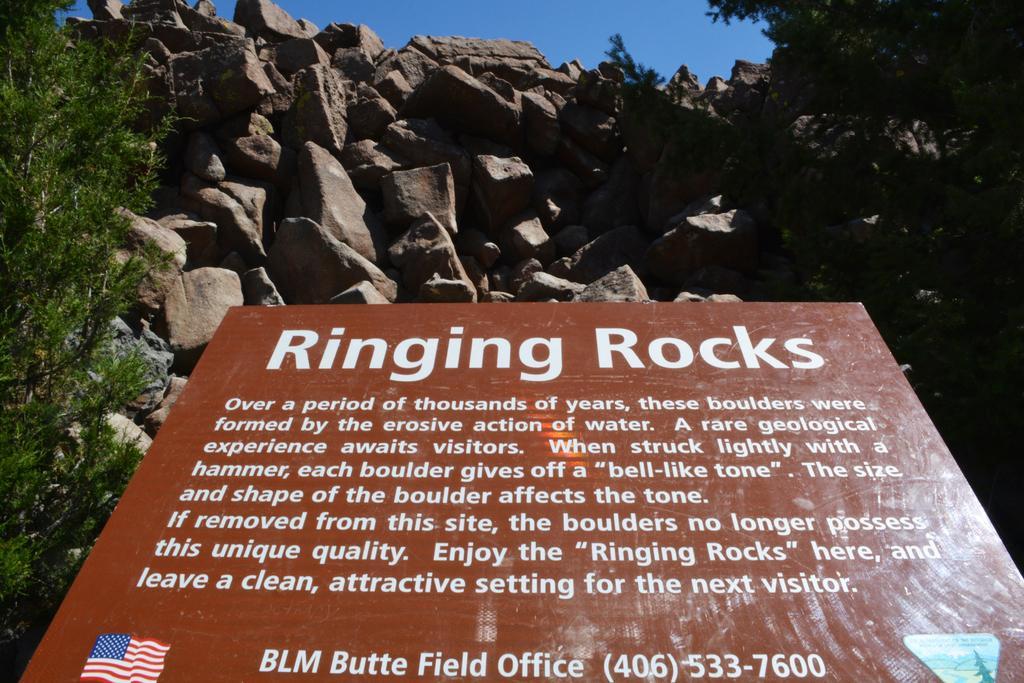Could you give a brief overview of what you see in this image? In this image I can see few rocks. On the left side I can see a tree. I can see a board with some text on it. At the top I can see the sky. 